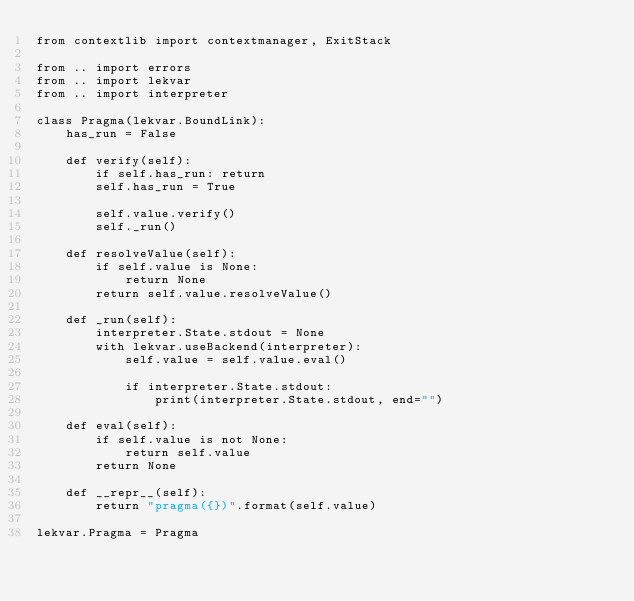<code> <loc_0><loc_0><loc_500><loc_500><_Python_>from contextlib import contextmanager, ExitStack

from .. import errors
from .. import lekvar
from .. import interpreter

class Pragma(lekvar.BoundLink):
    has_run = False

    def verify(self):
        if self.has_run: return
        self.has_run = True

        self.value.verify()
        self._run()

    def resolveValue(self):
        if self.value is None:
            return None
        return self.value.resolveValue()

    def _run(self):
        interpreter.State.stdout = None
        with lekvar.useBackend(interpreter):
            self.value = self.value.eval()

            if interpreter.State.stdout:
                print(interpreter.State.stdout, end="")

    def eval(self):
        if self.value is not None:
            return self.value
        return None

    def __repr__(self):
        return "pragma({})".format(self.value)

lekvar.Pragma = Pragma
</code> 